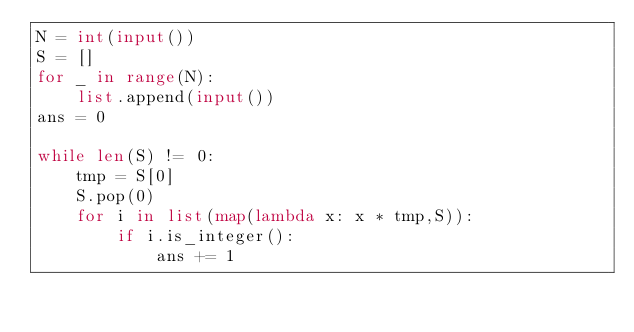Convert code to text. <code><loc_0><loc_0><loc_500><loc_500><_Python_>N = int(input())
S = []
for _ in range(N):
    list.append(input())
ans = 0
    
while len(S) != 0:
    tmp = S[0]
    S.pop(0)
    for i in list(map(lambda x: x * tmp,S)):
        if i.is_integer():
            ans += 1</code> 